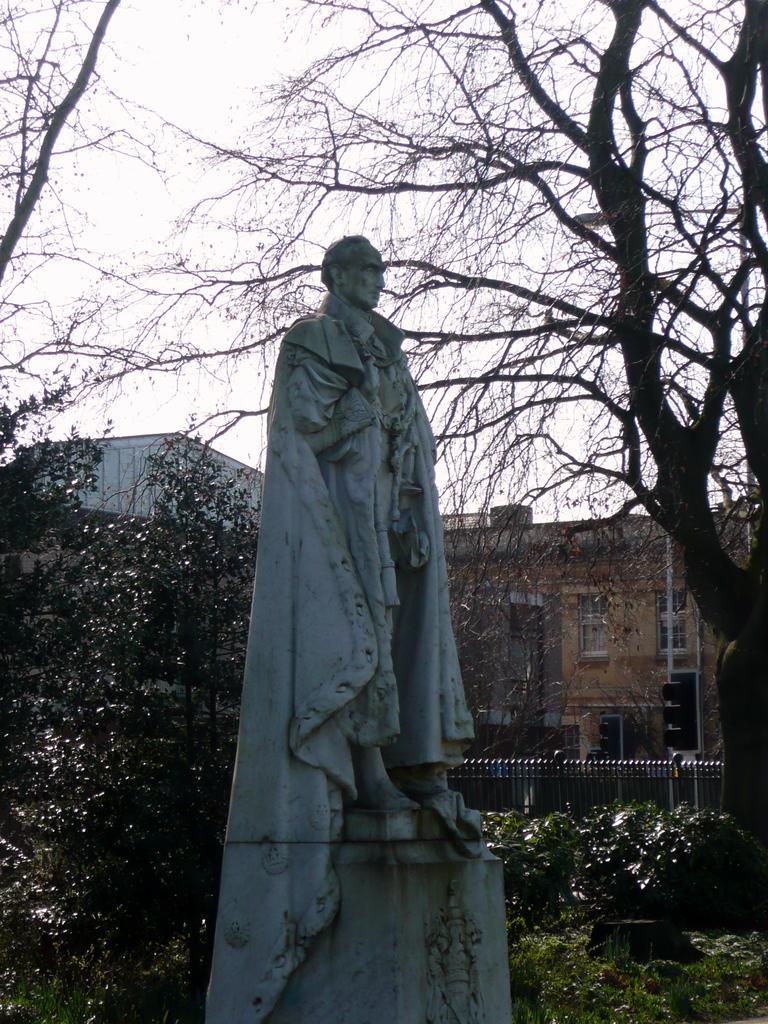How would you summarize this image in a sentence or two? In this image we can see a sculpture, there are some plants, trees, traffic lights and fence, in the background we can see the sky. 